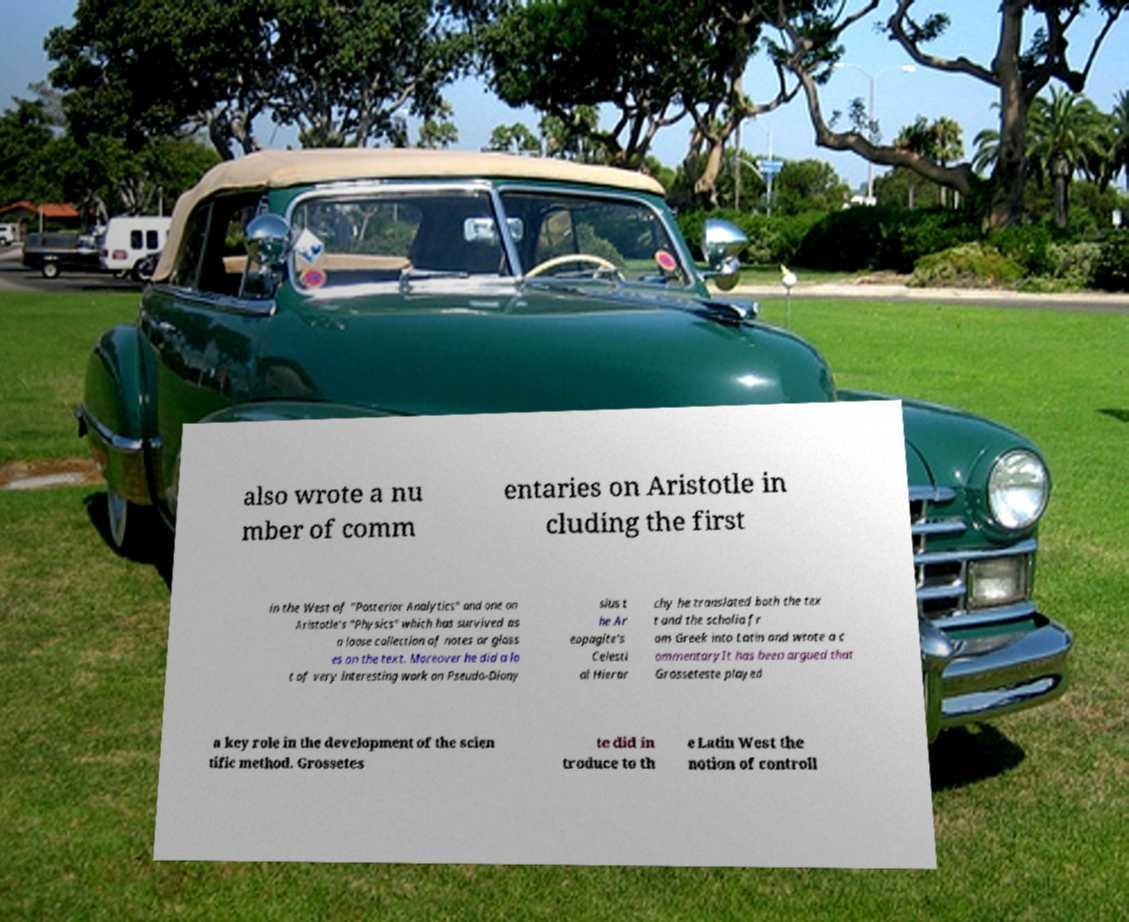Can you accurately transcribe the text from the provided image for me? also wrote a nu mber of comm entaries on Aristotle in cluding the first in the West of "Posterior Analytics" and one on Aristotle's "Physics" which has survived as a loose collection of notes or gloss es on the text. Moreover he did a lo t of very interesting work on Pseudo-Diony sius t he Ar eopagite's Celesti al Hierar chy he translated both the tex t and the scholia fr om Greek into Latin and wrote a c ommentaryIt has been argued that Grosseteste played a key role in the development of the scien tific method. Grossetes te did in troduce to th e Latin West the notion of controll 